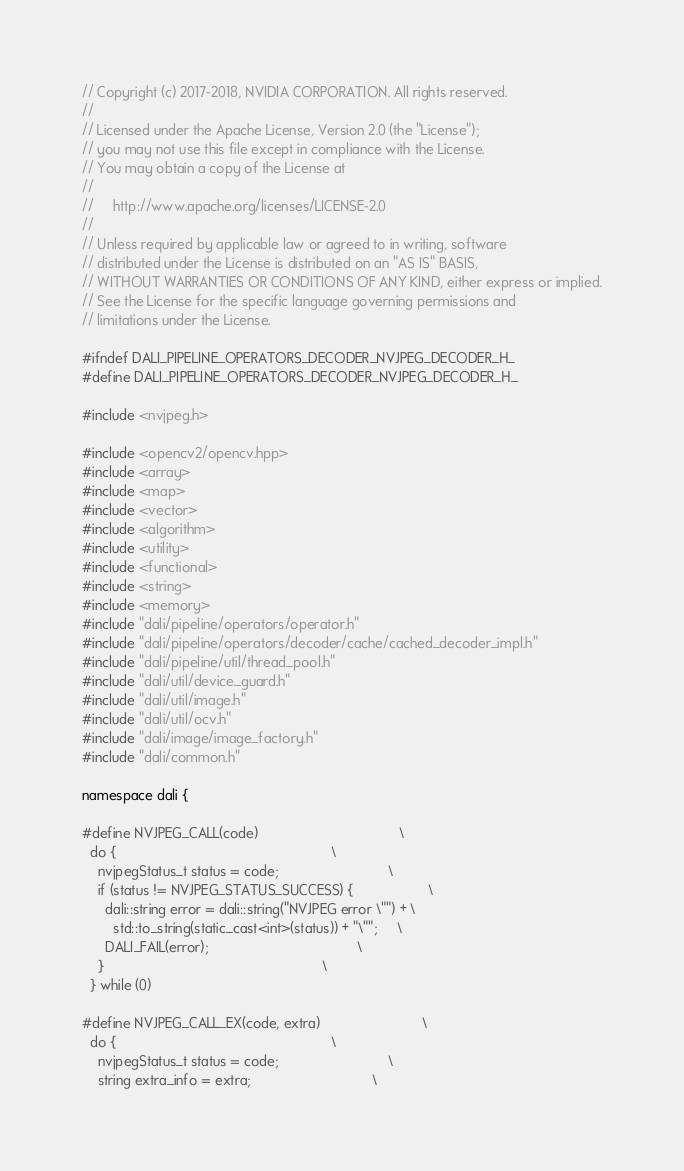<code> <loc_0><loc_0><loc_500><loc_500><_C_>// Copyright (c) 2017-2018, NVIDIA CORPORATION. All rights reserved.
//
// Licensed under the Apache License, Version 2.0 (the "License");
// you may not use this file except in compliance with the License.
// You may obtain a copy of the License at
//
//     http://www.apache.org/licenses/LICENSE-2.0
//
// Unless required by applicable law or agreed to in writing, software
// distributed under the License is distributed on an "AS IS" BASIS,
// WITHOUT WARRANTIES OR CONDITIONS OF ANY KIND, either express or implied.
// See the License for the specific language governing permissions and
// limitations under the License.

#ifndef DALI_PIPELINE_OPERATORS_DECODER_NVJPEG_DECODER_H_
#define DALI_PIPELINE_OPERATORS_DECODER_NVJPEG_DECODER_H_

#include <nvjpeg.h>

#include <opencv2/opencv.hpp>
#include <array>
#include <map>
#include <vector>
#include <algorithm>
#include <utility>
#include <functional>
#include <string>
#include <memory>
#include "dali/pipeline/operators/operator.h"
#include "dali/pipeline/operators/decoder/cache/cached_decoder_impl.h"
#include "dali/pipeline/util/thread_pool.h"
#include "dali/util/device_guard.h"
#include "dali/util/image.h"
#include "dali/util/ocv.h"
#include "dali/image/image_factory.h"
#include "dali/common.h"

namespace dali {

#define NVJPEG_CALL(code)                                    \
  do {                                                       \
    nvjpegStatus_t status = code;                            \
    if (status != NVJPEG_STATUS_SUCCESS) {                   \
      dali::string error = dali::string("NVJPEG error \"") + \
        std::to_string(static_cast<int>(status)) + "\"";     \
      DALI_FAIL(error);                                      \
    }                                                        \
  } while (0)

#define NVJPEG_CALL_EX(code, extra)                          \
  do {                                                       \
    nvjpegStatus_t status = code;                            \
    string extra_info = extra;                               \</code> 